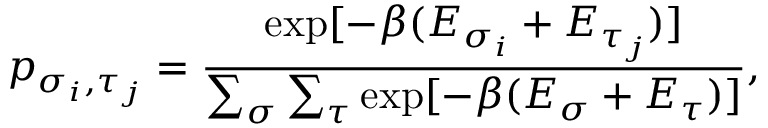Convert formula to latex. <formula><loc_0><loc_0><loc_500><loc_500>p _ { \sigma _ { i } , \tau _ { j } } = \frac { \exp [ - \beta ( E _ { \sigma _ { i } } + E _ { \tau _ { j } } ) ] } { \sum _ { \sigma } \sum _ { \tau } \exp [ - \beta ( E _ { \sigma } + E _ { \tau } ) ] } ,</formula> 